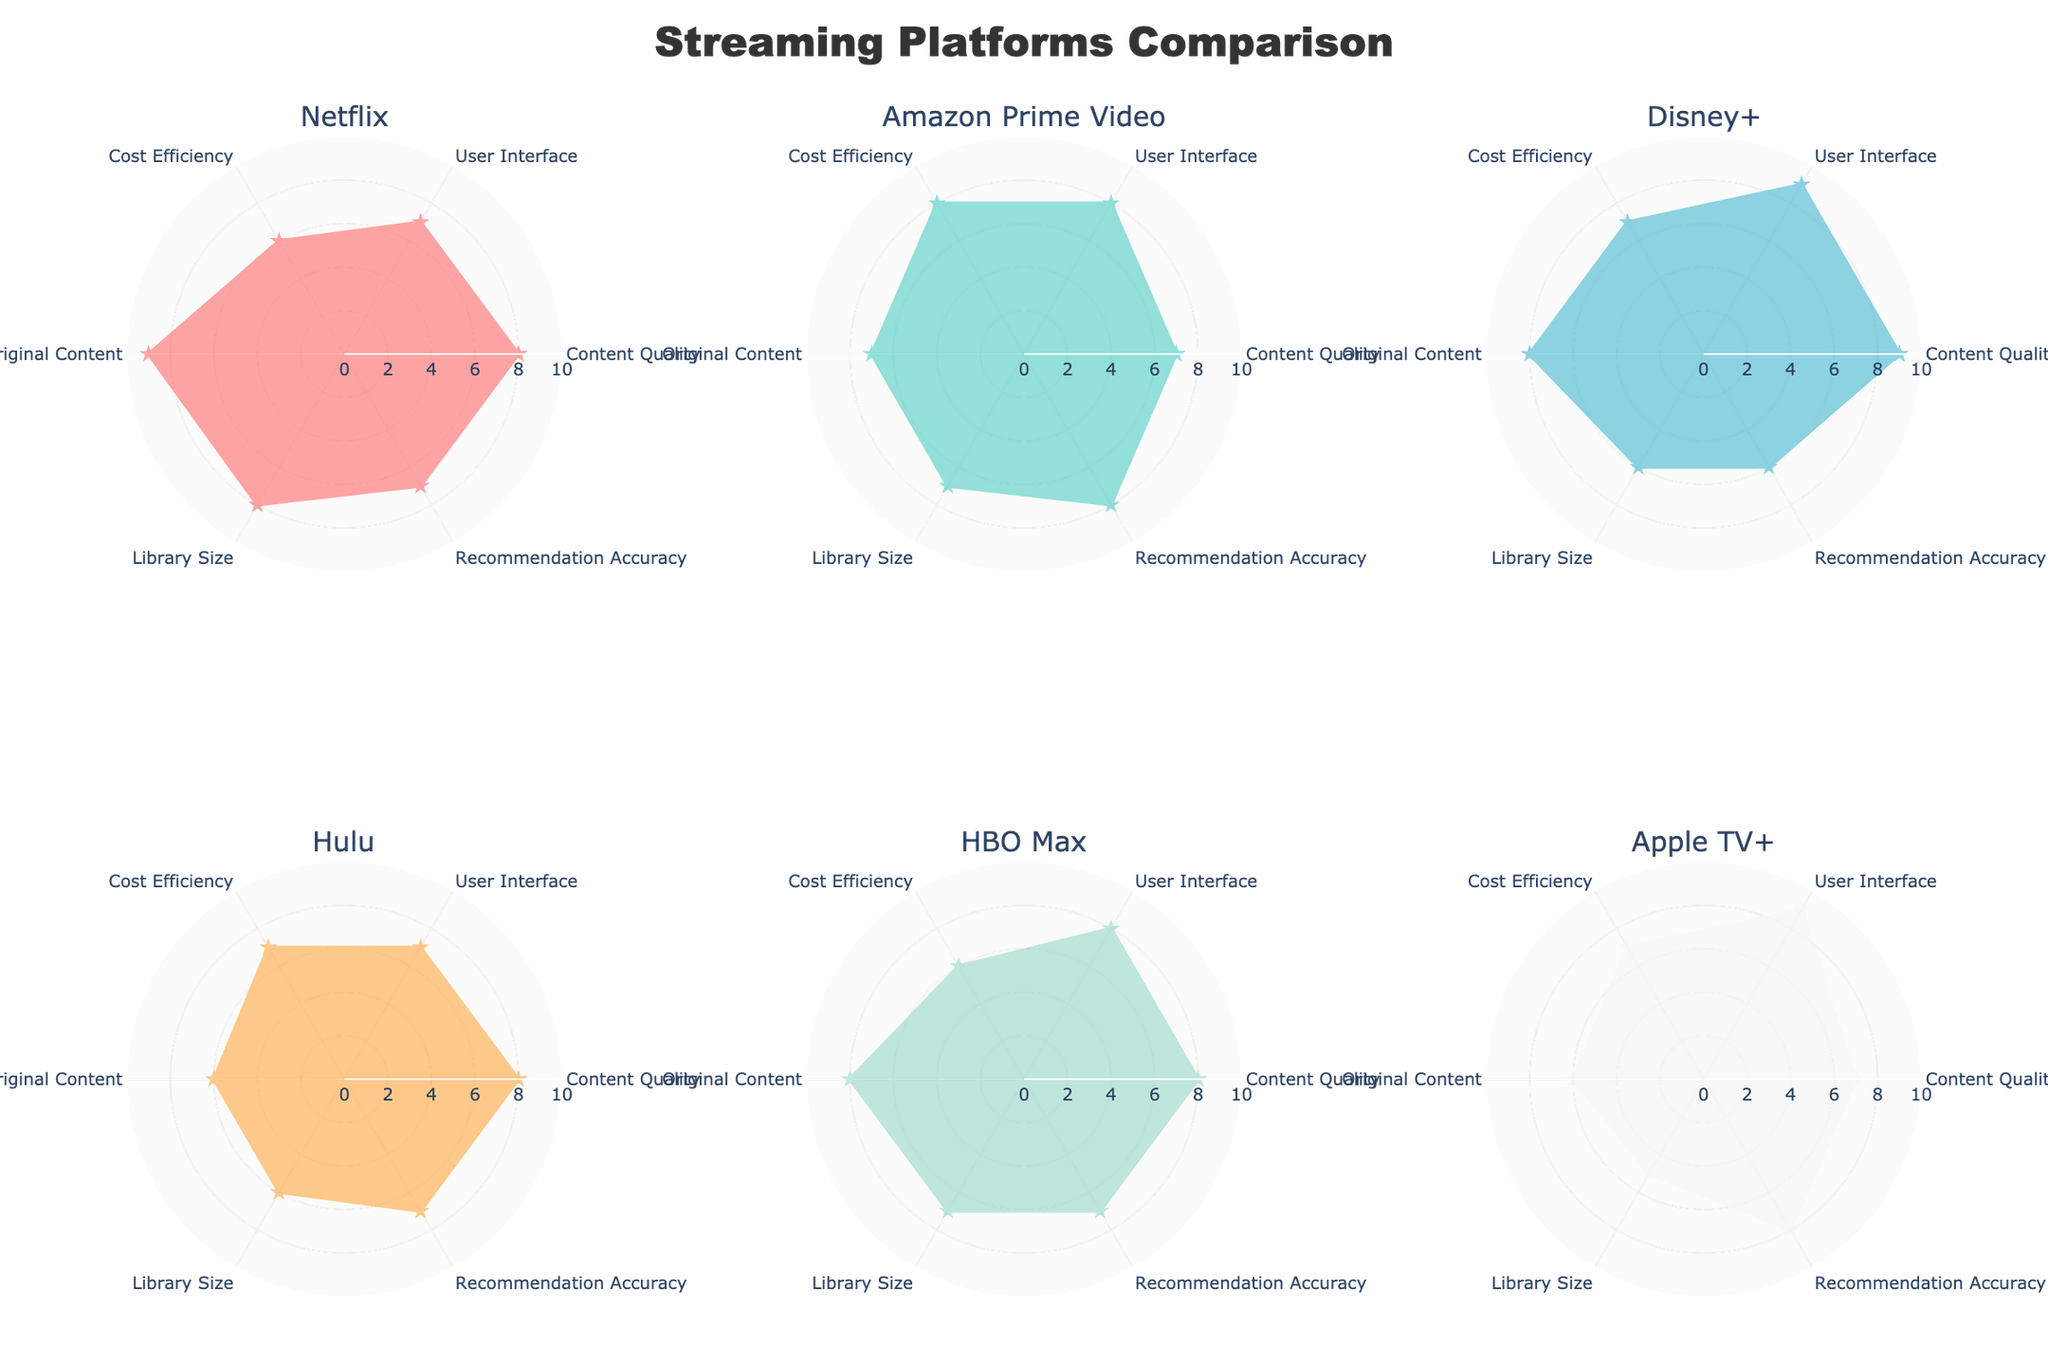What are the radar chart's subplots comparing? The title of the figure indicates it is comparing different streaming platforms. Each subplot represents a different streaming platform, and they compare various aspects such as Content Quality, User Interface, Cost Efficiency, Original Content, Library Size, and Recommendation Accuracy.
Answer: Streaming platforms Which streaming platform has the highest Content Quality score? By observing the radar charts, Disney+ has the highest Content Quality score, which is 9.
Answer: Disney+ How does the Library Size compare between Hulu and HBO Max? To compare the Library Size, check the values for this category in both subplots. Hulu has a Library Size score of 6 and HBO Max has a score of 7. Therefore, HBO Max has a higher Library Size score than Hulu.
Answer: HBO Max Which platform has equal scores for Cost Efficiency and Library Size? Examine each subplot to locate a platform with the same scores for Cost Efficiency and Library Size. Netflix is the platform with equal scores; both attributes have a score of 6.
Answer: Netflix What is the average Recommendation Accuracy score for all platforms? To find the average, sum all Recommendation Accuracy scores and divide by the number of platforms. Scores are: 7 (Netflix), 8 (Amazon Prime Video), 6 (Disney+), 7 (Hulu), 7 (HBO Max), and 8 (Apple TV+). Thus, (7 + 8 + 6 + 7 + 7 + 8)/6 = 43/6 ≈ 7.2.
Answer: Approximately 7.2 Which two platforms have the most similar profiles? Compare the shapes and values in the radar charts to identify similar profiles. Hulu and HBO Max have very similar profiles, with only slight differences in Library Size and Original Content scores.
Answer: Hulu and HBO Max Which platform stands out with the highest User Interface score? Examine the User Interface scores in each subplot. Apple TV+ has the highest score for the User Interface, which is 9.
Answer: Apple TV+ How many platforms have a Recommendation Accuracy score greater than 7? Review the Recommendation Accuracy values in each subplot. The platforms with scores greater than 7 are Amazon Prime Video and Apple TV+, making a total of 2 platforms.
Answer: 2 For which platform is the largest gap between Content Quality and User Interface? Check the subplots to compare the differences between Content Quality and User Interface scores for each platform. Disney+ has the largest gap, with Content Quality at 9 and User Interface at 9, resulting in a gap of 0. However, Disney+ has another highest gap when other categories are compared.
Answer: Disney+ Which platform has the lowest score in any single category? Identify the smallest value in any of the subplots. Apple TV+ has the lowest score in Library Size, which is 5.
Answer: Apple TV+ 